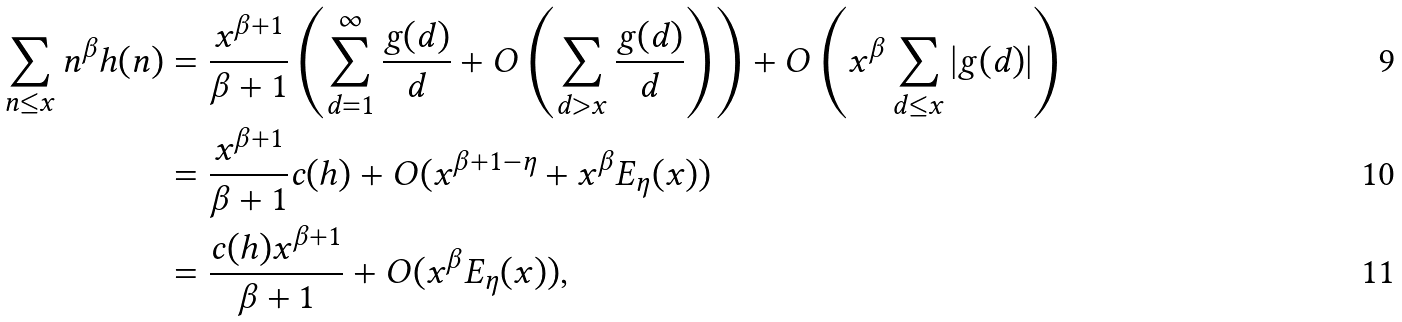<formula> <loc_0><loc_0><loc_500><loc_500>\sum _ { n \leq x } n ^ { \beta } h ( n ) & = \frac { x ^ { \beta + 1 } } { \beta + 1 } \left ( \sum _ { d = 1 } ^ { \infty } \frac { g ( d ) } d + O \left ( \sum _ { d > x } \frac { g ( d ) } d \right ) \right ) + O \left ( x ^ { \beta } \sum _ { d \leq x } | g ( d ) | \right ) \\ & = \frac { x ^ { \beta + 1 } } { \beta + 1 } c ( h ) + O ( x ^ { \beta + 1 - \eta } + x ^ { \beta } E _ { \eta } ( x ) ) \\ & = \frac { c ( h ) x ^ { \beta + 1 } } { \beta + 1 } + O ( x ^ { \beta } E _ { \eta } ( x ) ) ,</formula> 